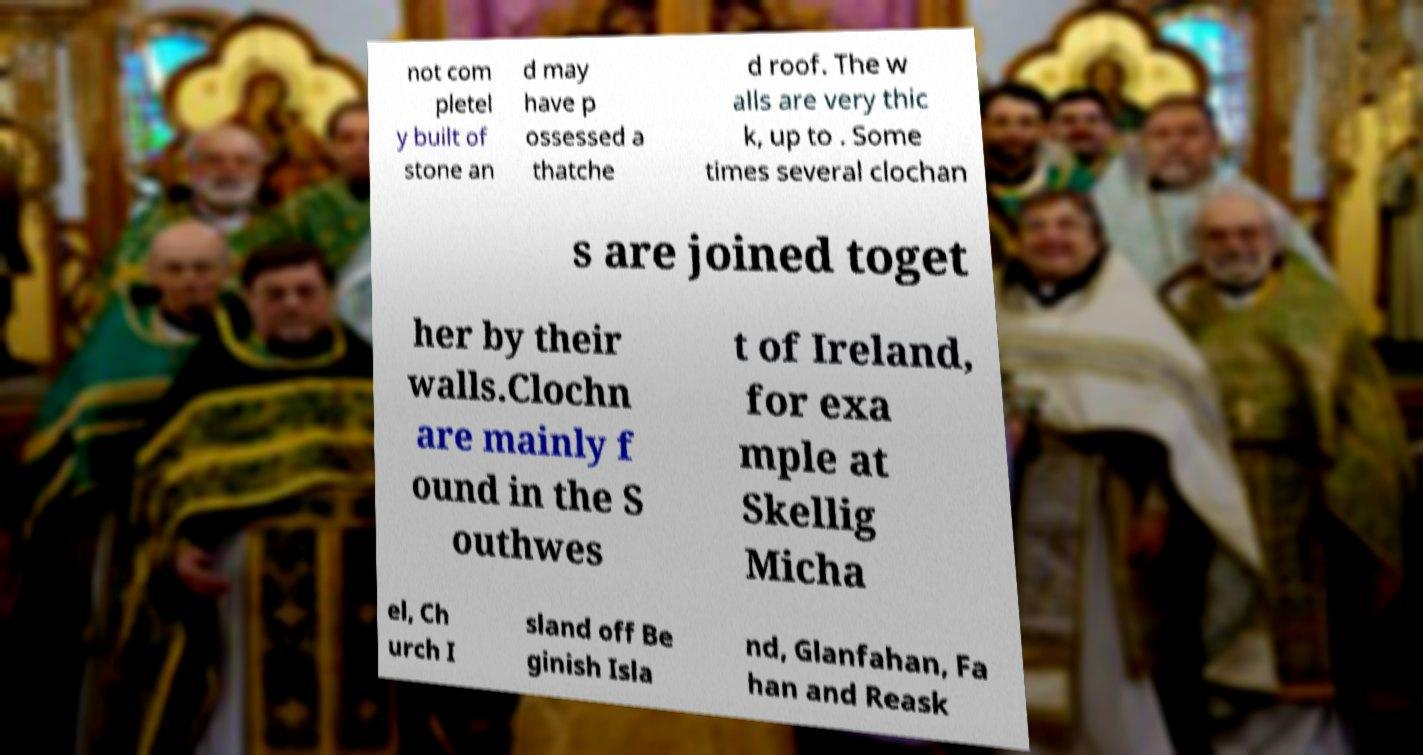Please read and relay the text visible in this image. What does it say? not com pletel y built of stone an d may have p ossessed a thatche d roof. The w alls are very thic k, up to . Some times several clochan s are joined toget her by their walls.Clochn are mainly f ound in the S outhwes t of Ireland, for exa mple at Skellig Micha el, Ch urch I sland off Be ginish Isla nd, Glanfahan, Fa han and Reask 